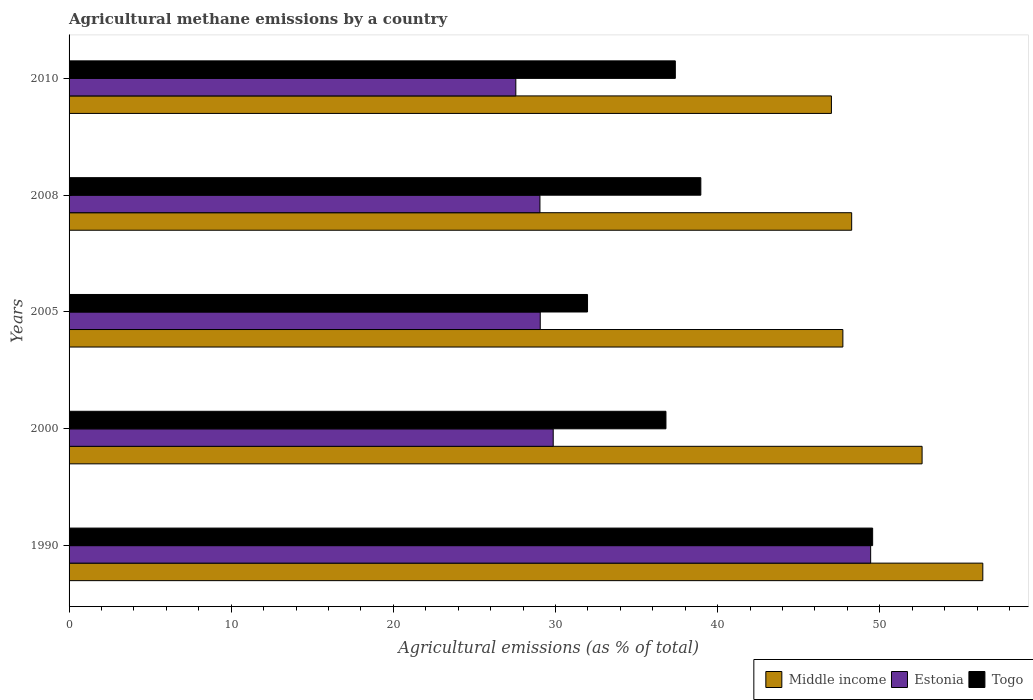How many groups of bars are there?
Give a very brief answer. 5. How many bars are there on the 1st tick from the bottom?
Ensure brevity in your answer.  3. What is the amount of agricultural methane emitted in Togo in 2008?
Make the answer very short. 38.96. Across all years, what is the maximum amount of agricultural methane emitted in Estonia?
Ensure brevity in your answer.  49.44. Across all years, what is the minimum amount of agricultural methane emitted in Estonia?
Ensure brevity in your answer.  27.55. In which year was the amount of agricultural methane emitted in Estonia minimum?
Offer a terse response. 2010. What is the total amount of agricultural methane emitted in Estonia in the graph?
Keep it short and to the point. 164.95. What is the difference between the amount of agricultural methane emitted in Estonia in 1990 and that in 2000?
Provide a short and direct response. 19.58. What is the difference between the amount of agricultural methane emitted in Middle income in 1990 and the amount of agricultural methane emitted in Togo in 2000?
Give a very brief answer. 19.54. What is the average amount of agricultural methane emitted in Togo per year?
Give a very brief answer. 38.94. In the year 1990, what is the difference between the amount of agricultural methane emitted in Middle income and amount of agricultural methane emitted in Togo?
Keep it short and to the point. 6.79. What is the ratio of the amount of agricultural methane emitted in Togo in 2000 to that in 2005?
Provide a succinct answer. 1.15. Is the amount of agricultural methane emitted in Togo in 2000 less than that in 2010?
Offer a terse response. Yes. What is the difference between the highest and the second highest amount of agricultural methane emitted in Middle income?
Ensure brevity in your answer.  3.74. What is the difference between the highest and the lowest amount of agricultural methane emitted in Estonia?
Provide a short and direct response. 21.88. In how many years, is the amount of agricultural methane emitted in Estonia greater than the average amount of agricultural methane emitted in Estonia taken over all years?
Offer a very short reply. 1. Is the sum of the amount of agricultural methane emitted in Togo in 1990 and 2008 greater than the maximum amount of agricultural methane emitted in Middle income across all years?
Ensure brevity in your answer.  Yes. What does the 2nd bar from the top in 2005 represents?
Keep it short and to the point. Estonia. What does the 2nd bar from the bottom in 2005 represents?
Make the answer very short. Estonia. Is it the case that in every year, the sum of the amount of agricultural methane emitted in Togo and amount of agricultural methane emitted in Middle income is greater than the amount of agricultural methane emitted in Estonia?
Offer a terse response. Yes. How many bars are there?
Provide a short and direct response. 15. What is the difference between two consecutive major ticks on the X-axis?
Keep it short and to the point. 10. Does the graph contain any zero values?
Your response must be concise. No. What is the title of the graph?
Your response must be concise. Agricultural methane emissions by a country. What is the label or title of the X-axis?
Make the answer very short. Agricultural emissions (as % of total). What is the label or title of the Y-axis?
Provide a short and direct response. Years. What is the Agricultural emissions (as % of total) of Middle income in 1990?
Keep it short and to the point. 56.35. What is the Agricultural emissions (as % of total) in Estonia in 1990?
Offer a very short reply. 49.44. What is the Agricultural emissions (as % of total) in Togo in 1990?
Provide a succinct answer. 49.56. What is the Agricultural emissions (as % of total) of Middle income in 2000?
Ensure brevity in your answer.  52.61. What is the Agricultural emissions (as % of total) of Estonia in 2000?
Offer a very short reply. 29.86. What is the Agricultural emissions (as % of total) in Togo in 2000?
Offer a very short reply. 36.81. What is the Agricultural emissions (as % of total) of Middle income in 2005?
Offer a very short reply. 47.72. What is the Agricultural emissions (as % of total) of Estonia in 2005?
Give a very brief answer. 29.06. What is the Agricultural emissions (as % of total) in Togo in 2005?
Your answer should be very brief. 31.98. What is the Agricultural emissions (as % of total) of Middle income in 2008?
Provide a short and direct response. 48.27. What is the Agricultural emissions (as % of total) of Estonia in 2008?
Ensure brevity in your answer.  29.04. What is the Agricultural emissions (as % of total) in Togo in 2008?
Your answer should be compact. 38.96. What is the Agricultural emissions (as % of total) of Middle income in 2010?
Your answer should be compact. 47.02. What is the Agricultural emissions (as % of total) in Estonia in 2010?
Offer a terse response. 27.55. What is the Agricultural emissions (as % of total) of Togo in 2010?
Keep it short and to the point. 37.39. Across all years, what is the maximum Agricultural emissions (as % of total) of Middle income?
Give a very brief answer. 56.35. Across all years, what is the maximum Agricultural emissions (as % of total) in Estonia?
Offer a terse response. 49.44. Across all years, what is the maximum Agricultural emissions (as % of total) of Togo?
Provide a succinct answer. 49.56. Across all years, what is the minimum Agricultural emissions (as % of total) in Middle income?
Offer a very short reply. 47.02. Across all years, what is the minimum Agricultural emissions (as % of total) of Estonia?
Your answer should be very brief. 27.55. Across all years, what is the minimum Agricultural emissions (as % of total) of Togo?
Your response must be concise. 31.98. What is the total Agricultural emissions (as % of total) of Middle income in the graph?
Your response must be concise. 251.97. What is the total Agricultural emissions (as % of total) of Estonia in the graph?
Your answer should be compact. 164.95. What is the total Agricultural emissions (as % of total) of Togo in the graph?
Give a very brief answer. 194.7. What is the difference between the Agricultural emissions (as % of total) of Middle income in 1990 and that in 2000?
Your answer should be very brief. 3.74. What is the difference between the Agricultural emissions (as % of total) in Estonia in 1990 and that in 2000?
Make the answer very short. 19.58. What is the difference between the Agricultural emissions (as % of total) of Togo in 1990 and that in 2000?
Offer a terse response. 12.75. What is the difference between the Agricultural emissions (as % of total) of Middle income in 1990 and that in 2005?
Provide a short and direct response. 8.63. What is the difference between the Agricultural emissions (as % of total) of Estonia in 1990 and that in 2005?
Offer a very short reply. 20.38. What is the difference between the Agricultural emissions (as % of total) of Togo in 1990 and that in 2005?
Your response must be concise. 17.58. What is the difference between the Agricultural emissions (as % of total) in Middle income in 1990 and that in 2008?
Your answer should be very brief. 8.09. What is the difference between the Agricultural emissions (as % of total) in Estonia in 1990 and that in 2008?
Provide a short and direct response. 20.4. What is the difference between the Agricultural emissions (as % of total) of Togo in 1990 and that in 2008?
Make the answer very short. 10.6. What is the difference between the Agricultural emissions (as % of total) of Middle income in 1990 and that in 2010?
Ensure brevity in your answer.  9.34. What is the difference between the Agricultural emissions (as % of total) in Estonia in 1990 and that in 2010?
Offer a very short reply. 21.88. What is the difference between the Agricultural emissions (as % of total) in Togo in 1990 and that in 2010?
Your answer should be compact. 12.17. What is the difference between the Agricultural emissions (as % of total) in Middle income in 2000 and that in 2005?
Provide a succinct answer. 4.89. What is the difference between the Agricultural emissions (as % of total) of Estonia in 2000 and that in 2005?
Offer a terse response. 0.8. What is the difference between the Agricultural emissions (as % of total) of Togo in 2000 and that in 2005?
Ensure brevity in your answer.  4.84. What is the difference between the Agricultural emissions (as % of total) in Middle income in 2000 and that in 2008?
Offer a very short reply. 4.34. What is the difference between the Agricultural emissions (as % of total) of Estonia in 2000 and that in 2008?
Give a very brief answer. 0.82. What is the difference between the Agricultural emissions (as % of total) in Togo in 2000 and that in 2008?
Offer a very short reply. -2.15. What is the difference between the Agricultural emissions (as % of total) in Middle income in 2000 and that in 2010?
Provide a succinct answer. 5.59. What is the difference between the Agricultural emissions (as % of total) in Estonia in 2000 and that in 2010?
Give a very brief answer. 2.31. What is the difference between the Agricultural emissions (as % of total) in Togo in 2000 and that in 2010?
Offer a very short reply. -0.58. What is the difference between the Agricultural emissions (as % of total) in Middle income in 2005 and that in 2008?
Your answer should be compact. -0.54. What is the difference between the Agricultural emissions (as % of total) in Estonia in 2005 and that in 2008?
Offer a terse response. 0.02. What is the difference between the Agricultural emissions (as % of total) in Togo in 2005 and that in 2008?
Give a very brief answer. -6.99. What is the difference between the Agricultural emissions (as % of total) of Middle income in 2005 and that in 2010?
Give a very brief answer. 0.71. What is the difference between the Agricultural emissions (as % of total) in Estonia in 2005 and that in 2010?
Provide a short and direct response. 1.51. What is the difference between the Agricultural emissions (as % of total) in Togo in 2005 and that in 2010?
Provide a succinct answer. -5.42. What is the difference between the Agricultural emissions (as % of total) in Middle income in 2008 and that in 2010?
Offer a terse response. 1.25. What is the difference between the Agricultural emissions (as % of total) in Estonia in 2008 and that in 2010?
Give a very brief answer. 1.49. What is the difference between the Agricultural emissions (as % of total) in Togo in 2008 and that in 2010?
Your answer should be very brief. 1.57. What is the difference between the Agricultural emissions (as % of total) in Middle income in 1990 and the Agricultural emissions (as % of total) in Estonia in 2000?
Make the answer very short. 26.49. What is the difference between the Agricultural emissions (as % of total) in Middle income in 1990 and the Agricultural emissions (as % of total) in Togo in 2000?
Your answer should be compact. 19.54. What is the difference between the Agricultural emissions (as % of total) in Estonia in 1990 and the Agricultural emissions (as % of total) in Togo in 2000?
Your answer should be very brief. 12.63. What is the difference between the Agricultural emissions (as % of total) of Middle income in 1990 and the Agricultural emissions (as % of total) of Estonia in 2005?
Ensure brevity in your answer.  27.29. What is the difference between the Agricultural emissions (as % of total) of Middle income in 1990 and the Agricultural emissions (as % of total) of Togo in 2005?
Your answer should be compact. 24.38. What is the difference between the Agricultural emissions (as % of total) of Estonia in 1990 and the Agricultural emissions (as % of total) of Togo in 2005?
Your answer should be compact. 17.46. What is the difference between the Agricultural emissions (as % of total) in Middle income in 1990 and the Agricultural emissions (as % of total) in Estonia in 2008?
Offer a terse response. 27.31. What is the difference between the Agricultural emissions (as % of total) of Middle income in 1990 and the Agricultural emissions (as % of total) of Togo in 2008?
Your answer should be compact. 17.39. What is the difference between the Agricultural emissions (as % of total) in Estonia in 1990 and the Agricultural emissions (as % of total) in Togo in 2008?
Your answer should be very brief. 10.47. What is the difference between the Agricultural emissions (as % of total) in Middle income in 1990 and the Agricultural emissions (as % of total) in Estonia in 2010?
Offer a terse response. 28.8. What is the difference between the Agricultural emissions (as % of total) in Middle income in 1990 and the Agricultural emissions (as % of total) in Togo in 2010?
Your answer should be compact. 18.96. What is the difference between the Agricultural emissions (as % of total) in Estonia in 1990 and the Agricultural emissions (as % of total) in Togo in 2010?
Make the answer very short. 12.05. What is the difference between the Agricultural emissions (as % of total) of Middle income in 2000 and the Agricultural emissions (as % of total) of Estonia in 2005?
Ensure brevity in your answer.  23.55. What is the difference between the Agricultural emissions (as % of total) of Middle income in 2000 and the Agricultural emissions (as % of total) of Togo in 2005?
Give a very brief answer. 20.63. What is the difference between the Agricultural emissions (as % of total) of Estonia in 2000 and the Agricultural emissions (as % of total) of Togo in 2005?
Your answer should be very brief. -2.12. What is the difference between the Agricultural emissions (as % of total) in Middle income in 2000 and the Agricultural emissions (as % of total) in Estonia in 2008?
Your answer should be very brief. 23.57. What is the difference between the Agricultural emissions (as % of total) of Middle income in 2000 and the Agricultural emissions (as % of total) of Togo in 2008?
Your answer should be compact. 13.65. What is the difference between the Agricultural emissions (as % of total) of Estonia in 2000 and the Agricultural emissions (as % of total) of Togo in 2008?
Your response must be concise. -9.1. What is the difference between the Agricultural emissions (as % of total) of Middle income in 2000 and the Agricultural emissions (as % of total) of Estonia in 2010?
Your answer should be very brief. 25.06. What is the difference between the Agricultural emissions (as % of total) of Middle income in 2000 and the Agricultural emissions (as % of total) of Togo in 2010?
Offer a terse response. 15.22. What is the difference between the Agricultural emissions (as % of total) in Estonia in 2000 and the Agricultural emissions (as % of total) in Togo in 2010?
Your response must be concise. -7.53. What is the difference between the Agricultural emissions (as % of total) in Middle income in 2005 and the Agricultural emissions (as % of total) in Estonia in 2008?
Keep it short and to the point. 18.68. What is the difference between the Agricultural emissions (as % of total) of Middle income in 2005 and the Agricultural emissions (as % of total) of Togo in 2008?
Your answer should be compact. 8.76. What is the difference between the Agricultural emissions (as % of total) of Estonia in 2005 and the Agricultural emissions (as % of total) of Togo in 2008?
Your answer should be very brief. -9.9. What is the difference between the Agricultural emissions (as % of total) of Middle income in 2005 and the Agricultural emissions (as % of total) of Estonia in 2010?
Your answer should be compact. 20.17. What is the difference between the Agricultural emissions (as % of total) in Middle income in 2005 and the Agricultural emissions (as % of total) in Togo in 2010?
Give a very brief answer. 10.33. What is the difference between the Agricultural emissions (as % of total) of Estonia in 2005 and the Agricultural emissions (as % of total) of Togo in 2010?
Offer a very short reply. -8.33. What is the difference between the Agricultural emissions (as % of total) in Middle income in 2008 and the Agricultural emissions (as % of total) in Estonia in 2010?
Your answer should be very brief. 20.71. What is the difference between the Agricultural emissions (as % of total) in Middle income in 2008 and the Agricultural emissions (as % of total) in Togo in 2010?
Give a very brief answer. 10.88. What is the difference between the Agricultural emissions (as % of total) of Estonia in 2008 and the Agricultural emissions (as % of total) of Togo in 2010?
Provide a short and direct response. -8.35. What is the average Agricultural emissions (as % of total) in Middle income per year?
Provide a succinct answer. 50.39. What is the average Agricultural emissions (as % of total) of Estonia per year?
Your response must be concise. 32.99. What is the average Agricultural emissions (as % of total) of Togo per year?
Your answer should be compact. 38.94. In the year 1990, what is the difference between the Agricultural emissions (as % of total) of Middle income and Agricultural emissions (as % of total) of Estonia?
Give a very brief answer. 6.92. In the year 1990, what is the difference between the Agricultural emissions (as % of total) in Middle income and Agricultural emissions (as % of total) in Togo?
Offer a terse response. 6.79. In the year 1990, what is the difference between the Agricultural emissions (as % of total) in Estonia and Agricultural emissions (as % of total) in Togo?
Your answer should be compact. -0.12. In the year 2000, what is the difference between the Agricultural emissions (as % of total) in Middle income and Agricultural emissions (as % of total) in Estonia?
Make the answer very short. 22.75. In the year 2000, what is the difference between the Agricultural emissions (as % of total) in Middle income and Agricultural emissions (as % of total) in Togo?
Ensure brevity in your answer.  15.8. In the year 2000, what is the difference between the Agricultural emissions (as % of total) of Estonia and Agricultural emissions (as % of total) of Togo?
Provide a short and direct response. -6.95. In the year 2005, what is the difference between the Agricultural emissions (as % of total) of Middle income and Agricultural emissions (as % of total) of Estonia?
Your response must be concise. 18.66. In the year 2005, what is the difference between the Agricultural emissions (as % of total) in Middle income and Agricultural emissions (as % of total) in Togo?
Give a very brief answer. 15.75. In the year 2005, what is the difference between the Agricultural emissions (as % of total) of Estonia and Agricultural emissions (as % of total) of Togo?
Give a very brief answer. -2.92. In the year 2008, what is the difference between the Agricultural emissions (as % of total) of Middle income and Agricultural emissions (as % of total) of Estonia?
Give a very brief answer. 19.23. In the year 2008, what is the difference between the Agricultural emissions (as % of total) of Middle income and Agricultural emissions (as % of total) of Togo?
Give a very brief answer. 9.3. In the year 2008, what is the difference between the Agricultural emissions (as % of total) of Estonia and Agricultural emissions (as % of total) of Togo?
Keep it short and to the point. -9.92. In the year 2010, what is the difference between the Agricultural emissions (as % of total) in Middle income and Agricultural emissions (as % of total) in Estonia?
Offer a very short reply. 19.46. In the year 2010, what is the difference between the Agricultural emissions (as % of total) in Middle income and Agricultural emissions (as % of total) in Togo?
Your answer should be compact. 9.63. In the year 2010, what is the difference between the Agricultural emissions (as % of total) of Estonia and Agricultural emissions (as % of total) of Togo?
Provide a short and direct response. -9.84. What is the ratio of the Agricultural emissions (as % of total) of Middle income in 1990 to that in 2000?
Make the answer very short. 1.07. What is the ratio of the Agricultural emissions (as % of total) in Estonia in 1990 to that in 2000?
Give a very brief answer. 1.66. What is the ratio of the Agricultural emissions (as % of total) of Togo in 1990 to that in 2000?
Offer a terse response. 1.35. What is the ratio of the Agricultural emissions (as % of total) of Middle income in 1990 to that in 2005?
Your response must be concise. 1.18. What is the ratio of the Agricultural emissions (as % of total) of Estonia in 1990 to that in 2005?
Your answer should be very brief. 1.7. What is the ratio of the Agricultural emissions (as % of total) in Togo in 1990 to that in 2005?
Give a very brief answer. 1.55. What is the ratio of the Agricultural emissions (as % of total) in Middle income in 1990 to that in 2008?
Your response must be concise. 1.17. What is the ratio of the Agricultural emissions (as % of total) in Estonia in 1990 to that in 2008?
Provide a succinct answer. 1.7. What is the ratio of the Agricultural emissions (as % of total) in Togo in 1990 to that in 2008?
Offer a terse response. 1.27. What is the ratio of the Agricultural emissions (as % of total) in Middle income in 1990 to that in 2010?
Your response must be concise. 1.2. What is the ratio of the Agricultural emissions (as % of total) of Estonia in 1990 to that in 2010?
Provide a succinct answer. 1.79. What is the ratio of the Agricultural emissions (as % of total) in Togo in 1990 to that in 2010?
Your response must be concise. 1.33. What is the ratio of the Agricultural emissions (as % of total) of Middle income in 2000 to that in 2005?
Offer a very short reply. 1.1. What is the ratio of the Agricultural emissions (as % of total) of Estonia in 2000 to that in 2005?
Keep it short and to the point. 1.03. What is the ratio of the Agricultural emissions (as % of total) of Togo in 2000 to that in 2005?
Provide a succinct answer. 1.15. What is the ratio of the Agricultural emissions (as % of total) in Middle income in 2000 to that in 2008?
Give a very brief answer. 1.09. What is the ratio of the Agricultural emissions (as % of total) in Estonia in 2000 to that in 2008?
Your response must be concise. 1.03. What is the ratio of the Agricultural emissions (as % of total) of Togo in 2000 to that in 2008?
Provide a succinct answer. 0.94. What is the ratio of the Agricultural emissions (as % of total) in Middle income in 2000 to that in 2010?
Your answer should be compact. 1.12. What is the ratio of the Agricultural emissions (as % of total) in Estonia in 2000 to that in 2010?
Ensure brevity in your answer.  1.08. What is the ratio of the Agricultural emissions (as % of total) in Togo in 2000 to that in 2010?
Offer a terse response. 0.98. What is the ratio of the Agricultural emissions (as % of total) of Middle income in 2005 to that in 2008?
Provide a short and direct response. 0.99. What is the ratio of the Agricultural emissions (as % of total) in Togo in 2005 to that in 2008?
Offer a very short reply. 0.82. What is the ratio of the Agricultural emissions (as % of total) of Estonia in 2005 to that in 2010?
Provide a succinct answer. 1.05. What is the ratio of the Agricultural emissions (as % of total) in Togo in 2005 to that in 2010?
Your answer should be very brief. 0.86. What is the ratio of the Agricultural emissions (as % of total) of Middle income in 2008 to that in 2010?
Offer a terse response. 1.03. What is the ratio of the Agricultural emissions (as % of total) in Estonia in 2008 to that in 2010?
Offer a very short reply. 1.05. What is the ratio of the Agricultural emissions (as % of total) in Togo in 2008 to that in 2010?
Provide a short and direct response. 1.04. What is the difference between the highest and the second highest Agricultural emissions (as % of total) of Middle income?
Your answer should be very brief. 3.74. What is the difference between the highest and the second highest Agricultural emissions (as % of total) of Estonia?
Make the answer very short. 19.58. What is the difference between the highest and the second highest Agricultural emissions (as % of total) of Togo?
Offer a very short reply. 10.6. What is the difference between the highest and the lowest Agricultural emissions (as % of total) in Middle income?
Your answer should be compact. 9.34. What is the difference between the highest and the lowest Agricultural emissions (as % of total) of Estonia?
Ensure brevity in your answer.  21.88. What is the difference between the highest and the lowest Agricultural emissions (as % of total) of Togo?
Keep it short and to the point. 17.58. 